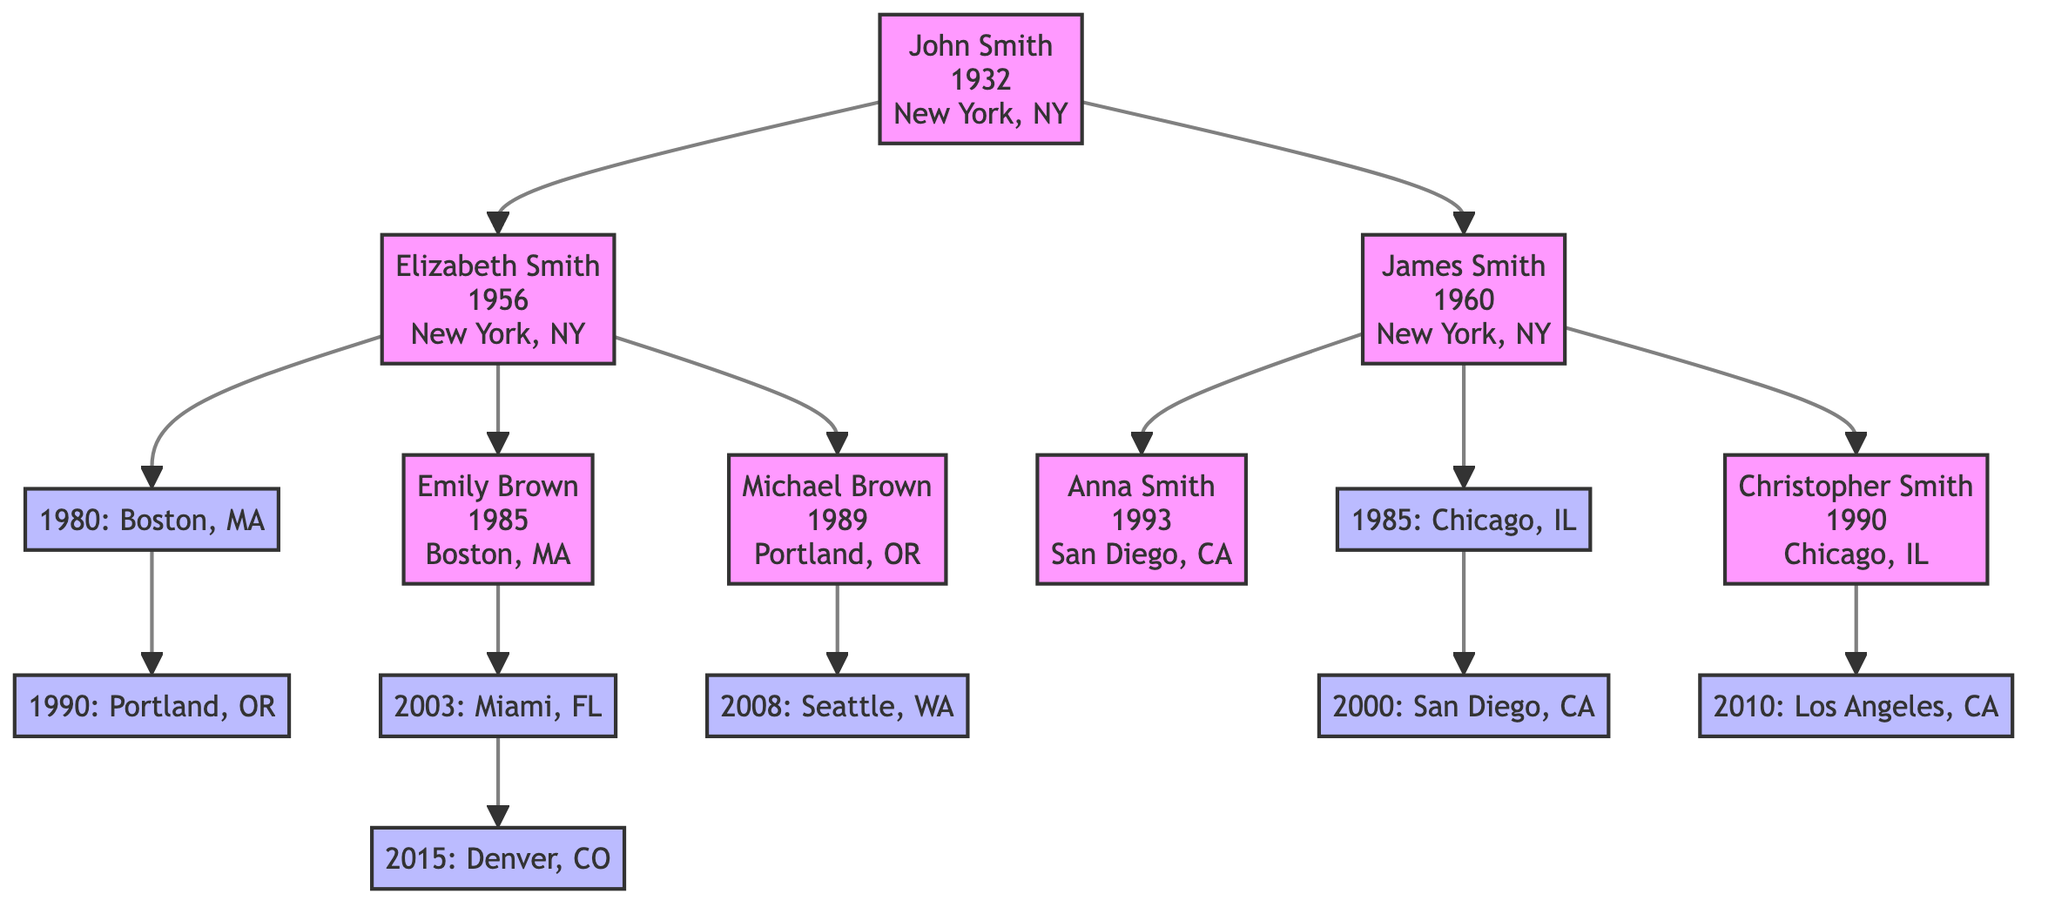What is the birth place of John Smith? The diagram shows that John Smith was born in New York, NY, as indicated directly next to his name.
Answer: New York, NY How many children does Elizabeth Smith have? By examining the diagram, we can see that there are two children listed under Elizabeth Smith: Emily Brown and Michael Brown.
Answer: 2 What year did James Smith migrate to San Diego, CA? The migration path for James Smith is specified in the diagram, showing that he migrated to San Diego, CA in the year 2000.
Answer: 2000 Which city did Emily Brown migrate to in 2015? The migration record for Emily Brown indicates that she moved to Denver, CO in 2015, as detailed in her migration list connected to her node.
Answer: Denver, CO Who is the parent of Christopher Smith? The diagram shows that Christopher Smith is a child of James Smith, as he is directly connected to this node.
Answer: James Smith How many total migrations are noted for the family? To find the total number of migrations, we will count each migration listed under each family member. Elizabeth Smith has 2, Emily Brown has 2, Michael Brown has 1, and James Smith has 2, totaling 7 migrations overall.
Answer: 7 What is the chain of migration for Emily Brown? By following the migrations listed for Emily Brown, she moved first to Miami, FL in 2003, then to Denver, CO in 2015. This sequential data gives us the complete migration pathway.
Answer: Miami, FL; Denver, CO Which family member was born first, Michael Brown or Anna Smith? Checking the birth years listed in the nodes, Michael Brown was born in 1989 and Anna Smith was born in 1993. Since 1989 is earlier than 1993, Michael Brown is the older sibling.
Answer: Michael Brown Where was James Smith born? The diagram explicitly states that James Smith was born in New York, NY, as shown next to his name.
Answer: New York, NY 